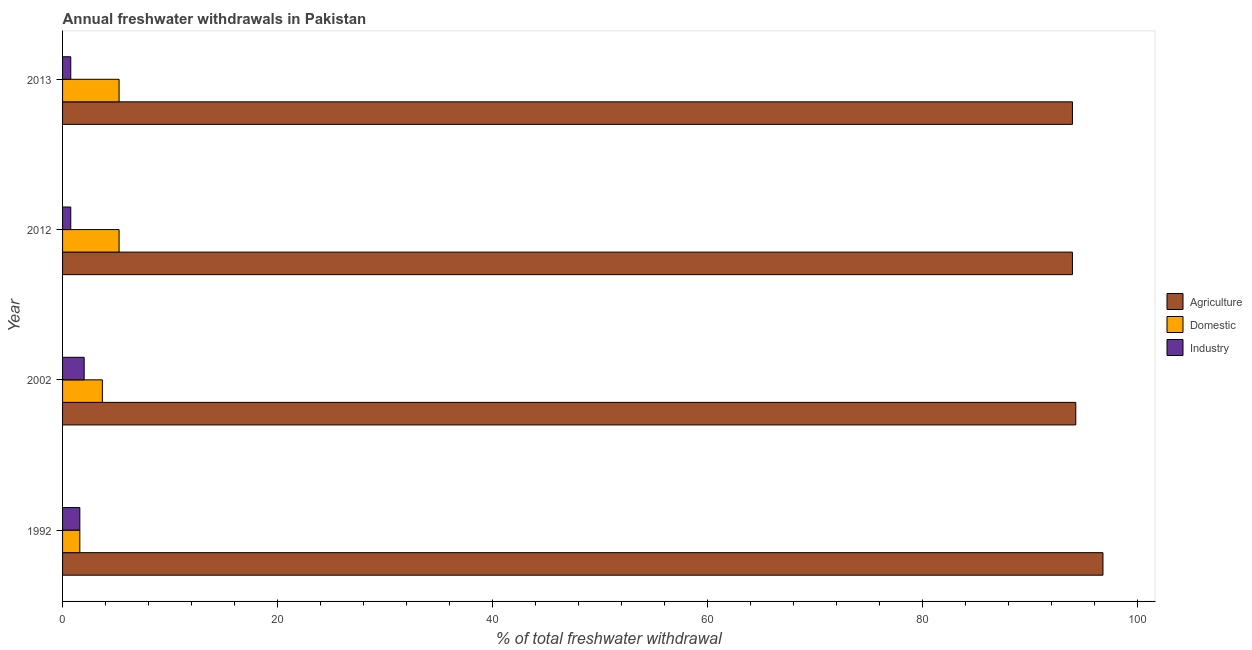How many different coloured bars are there?
Provide a short and direct response. 3. How many groups of bars are there?
Give a very brief answer. 4. Are the number of bars per tick equal to the number of legend labels?
Offer a very short reply. Yes. How many bars are there on the 1st tick from the top?
Your answer should be compact. 3. What is the label of the 3rd group of bars from the top?
Your response must be concise. 2002. In how many cases, is the number of bars for a given year not equal to the number of legend labels?
Your answer should be compact. 0. What is the percentage of freshwater withdrawal for industry in 2012?
Offer a very short reply. 0.76. Across all years, what is the maximum percentage of freshwater withdrawal for agriculture?
Offer a terse response. 96.79. Across all years, what is the minimum percentage of freshwater withdrawal for agriculture?
Offer a very short reply. 93.95. In which year was the percentage of freshwater withdrawal for domestic purposes minimum?
Keep it short and to the point. 1992. What is the total percentage of freshwater withdrawal for agriculture in the graph?
Your answer should be compact. 378.95. What is the difference between the percentage of freshwater withdrawal for industry in 2002 and that in 2012?
Ensure brevity in your answer.  1.25. What is the difference between the percentage of freshwater withdrawal for industry in 2012 and the percentage of freshwater withdrawal for agriculture in 2013?
Make the answer very short. -93.19. What is the average percentage of freshwater withdrawal for agriculture per year?
Provide a short and direct response. 94.74. In the year 2012, what is the difference between the percentage of freshwater withdrawal for agriculture and percentage of freshwater withdrawal for industry?
Your answer should be very brief. 93.19. In how many years, is the percentage of freshwater withdrawal for agriculture greater than 88 %?
Your response must be concise. 4. Is the percentage of freshwater withdrawal for domestic purposes in 1992 less than that in 2002?
Offer a terse response. Yes. Is the difference between the percentage of freshwater withdrawal for domestic purposes in 2002 and 2013 greater than the difference between the percentage of freshwater withdrawal for agriculture in 2002 and 2013?
Offer a very short reply. No. What is the difference between the highest and the lowest percentage of freshwater withdrawal for domestic purposes?
Provide a succinct answer. 3.65. In how many years, is the percentage of freshwater withdrawal for domestic purposes greater than the average percentage of freshwater withdrawal for domestic purposes taken over all years?
Your answer should be very brief. 2. Is the sum of the percentage of freshwater withdrawal for domestic purposes in 2002 and 2012 greater than the maximum percentage of freshwater withdrawal for industry across all years?
Your answer should be very brief. Yes. What does the 2nd bar from the top in 2002 represents?
Make the answer very short. Domestic. What does the 3rd bar from the bottom in 2012 represents?
Your answer should be very brief. Industry. How many bars are there?
Your answer should be compact. 12. How many years are there in the graph?
Give a very brief answer. 4. Are the values on the major ticks of X-axis written in scientific E-notation?
Keep it short and to the point. No. Does the graph contain any zero values?
Ensure brevity in your answer.  No. How many legend labels are there?
Give a very brief answer. 3. What is the title of the graph?
Offer a terse response. Annual freshwater withdrawals in Pakistan. What is the label or title of the X-axis?
Give a very brief answer. % of total freshwater withdrawal. What is the % of total freshwater withdrawal of Agriculture in 1992?
Provide a succinct answer. 96.79. What is the % of total freshwater withdrawal of Domestic in 1992?
Your answer should be very brief. 1.61. What is the % of total freshwater withdrawal of Industry in 1992?
Keep it short and to the point. 1.61. What is the % of total freshwater withdrawal in Agriculture in 2002?
Give a very brief answer. 94.26. What is the % of total freshwater withdrawal of Domestic in 2002?
Offer a very short reply. 3.7. What is the % of total freshwater withdrawal of Industry in 2002?
Provide a succinct answer. 2.01. What is the % of total freshwater withdrawal in Agriculture in 2012?
Your answer should be compact. 93.95. What is the % of total freshwater withdrawal in Domestic in 2012?
Provide a short and direct response. 5.26. What is the % of total freshwater withdrawal in Industry in 2012?
Make the answer very short. 0.76. What is the % of total freshwater withdrawal in Agriculture in 2013?
Provide a short and direct response. 93.95. What is the % of total freshwater withdrawal of Domestic in 2013?
Offer a terse response. 5.26. What is the % of total freshwater withdrawal of Industry in 2013?
Make the answer very short. 0.76. Across all years, what is the maximum % of total freshwater withdrawal of Agriculture?
Ensure brevity in your answer.  96.79. Across all years, what is the maximum % of total freshwater withdrawal in Domestic?
Offer a terse response. 5.26. Across all years, what is the maximum % of total freshwater withdrawal of Industry?
Your response must be concise. 2.01. Across all years, what is the minimum % of total freshwater withdrawal of Agriculture?
Your response must be concise. 93.95. Across all years, what is the minimum % of total freshwater withdrawal of Domestic?
Your answer should be compact. 1.61. Across all years, what is the minimum % of total freshwater withdrawal in Industry?
Offer a very short reply. 0.76. What is the total % of total freshwater withdrawal of Agriculture in the graph?
Offer a very short reply. 378.95. What is the total % of total freshwater withdrawal of Domestic in the graph?
Provide a succinct answer. 15.83. What is the total % of total freshwater withdrawal in Industry in the graph?
Offer a very short reply. 5.14. What is the difference between the % of total freshwater withdrawal of Agriculture in 1992 and that in 2002?
Make the answer very short. 2.53. What is the difference between the % of total freshwater withdrawal of Domestic in 1992 and that in 2002?
Your response must be concise. -2.1. What is the difference between the % of total freshwater withdrawal in Industry in 1992 and that in 2002?
Your response must be concise. -0.4. What is the difference between the % of total freshwater withdrawal of Agriculture in 1992 and that in 2012?
Your response must be concise. 2.84. What is the difference between the % of total freshwater withdrawal of Domestic in 1992 and that in 2012?
Offer a terse response. -3.65. What is the difference between the % of total freshwater withdrawal of Industry in 1992 and that in 2012?
Give a very brief answer. 0.84. What is the difference between the % of total freshwater withdrawal of Agriculture in 1992 and that in 2013?
Make the answer very short. 2.84. What is the difference between the % of total freshwater withdrawal of Domestic in 1992 and that in 2013?
Provide a short and direct response. -3.65. What is the difference between the % of total freshwater withdrawal of Industry in 1992 and that in 2013?
Provide a short and direct response. 0.84. What is the difference between the % of total freshwater withdrawal of Agriculture in 2002 and that in 2012?
Offer a terse response. 0.31. What is the difference between the % of total freshwater withdrawal in Domestic in 2002 and that in 2012?
Make the answer very short. -1.56. What is the difference between the % of total freshwater withdrawal in Industry in 2002 and that in 2012?
Provide a short and direct response. 1.25. What is the difference between the % of total freshwater withdrawal of Agriculture in 2002 and that in 2013?
Give a very brief answer. 0.31. What is the difference between the % of total freshwater withdrawal in Domestic in 2002 and that in 2013?
Provide a succinct answer. -1.56. What is the difference between the % of total freshwater withdrawal of Industry in 2002 and that in 2013?
Your response must be concise. 1.25. What is the difference between the % of total freshwater withdrawal in Industry in 2012 and that in 2013?
Provide a succinct answer. 0. What is the difference between the % of total freshwater withdrawal in Agriculture in 1992 and the % of total freshwater withdrawal in Domestic in 2002?
Offer a very short reply. 93.09. What is the difference between the % of total freshwater withdrawal of Agriculture in 1992 and the % of total freshwater withdrawal of Industry in 2002?
Ensure brevity in your answer.  94.78. What is the difference between the % of total freshwater withdrawal in Domestic in 1992 and the % of total freshwater withdrawal in Industry in 2002?
Provide a succinct answer. -0.4. What is the difference between the % of total freshwater withdrawal of Agriculture in 1992 and the % of total freshwater withdrawal of Domestic in 2012?
Your response must be concise. 91.53. What is the difference between the % of total freshwater withdrawal of Agriculture in 1992 and the % of total freshwater withdrawal of Industry in 2012?
Your response must be concise. 96.03. What is the difference between the % of total freshwater withdrawal in Domestic in 1992 and the % of total freshwater withdrawal in Industry in 2012?
Your response must be concise. 0.84. What is the difference between the % of total freshwater withdrawal of Agriculture in 1992 and the % of total freshwater withdrawal of Domestic in 2013?
Make the answer very short. 91.53. What is the difference between the % of total freshwater withdrawal of Agriculture in 1992 and the % of total freshwater withdrawal of Industry in 2013?
Offer a very short reply. 96.03. What is the difference between the % of total freshwater withdrawal of Domestic in 1992 and the % of total freshwater withdrawal of Industry in 2013?
Provide a short and direct response. 0.84. What is the difference between the % of total freshwater withdrawal of Agriculture in 2002 and the % of total freshwater withdrawal of Domestic in 2012?
Offer a terse response. 89. What is the difference between the % of total freshwater withdrawal of Agriculture in 2002 and the % of total freshwater withdrawal of Industry in 2012?
Your response must be concise. 93.5. What is the difference between the % of total freshwater withdrawal of Domestic in 2002 and the % of total freshwater withdrawal of Industry in 2012?
Keep it short and to the point. 2.94. What is the difference between the % of total freshwater withdrawal in Agriculture in 2002 and the % of total freshwater withdrawal in Domestic in 2013?
Offer a terse response. 89. What is the difference between the % of total freshwater withdrawal of Agriculture in 2002 and the % of total freshwater withdrawal of Industry in 2013?
Provide a succinct answer. 93.5. What is the difference between the % of total freshwater withdrawal in Domestic in 2002 and the % of total freshwater withdrawal in Industry in 2013?
Provide a succinct answer. 2.94. What is the difference between the % of total freshwater withdrawal of Agriculture in 2012 and the % of total freshwater withdrawal of Domestic in 2013?
Your answer should be very brief. 88.69. What is the difference between the % of total freshwater withdrawal of Agriculture in 2012 and the % of total freshwater withdrawal of Industry in 2013?
Provide a succinct answer. 93.19. What is the difference between the % of total freshwater withdrawal of Domestic in 2012 and the % of total freshwater withdrawal of Industry in 2013?
Keep it short and to the point. 4.5. What is the average % of total freshwater withdrawal of Agriculture per year?
Ensure brevity in your answer.  94.74. What is the average % of total freshwater withdrawal in Domestic per year?
Offer a very short reply. 3.96. In the year 1992, what is the difference between the % of total freshwater withdrawal of Agriculture and % of total freshwater withdrawal of Domestic?
Ensure brevity in your answer.  95.18. In the year 1992, what is the difference between the % of total freshwater withdrawal in Agriculture and % of total freshwater withdrawal in Industry?
Your response must be concise. 95.18. In the year 1992, what is the difference between the % of total freshwater withdrawal of Domestic and % of total freshwater withdrawal of Industry?
Your answer should be compact. 0. In the year 2002, what is the difference between the % of total freshwater withdrawal in Agriculture and % of total freshwater withdrawal in Domestic?
Keep it short and to the point. 90.56. In the year 2002, what is the difference between the % of total freshwater withdrawal in Agriculture and % of total freshwater withdrawal in Industry?
Make the answer very short. 92.25. In the year 2002, what is the difference between the % of total freshwater withdrawal in Domestic and % of total freshwater withdrawal in Industry?
Your response must be concise. 1.69. In the year 2012, what is the difference between the % of total freshwater withdrawal of Agriculture and % of total freshwater withdrawal of Domestic?
Offer a terse response. 88.69. In the year 2012, what is the difference between the % of total freshwater withdrawal in Agriculture and % of total freshwater withdrawal in Industry?
Your answer should be compact. 93.19. In the year 2012, what is the difference between the % of total freshwater withdrawal in Domestic and % of total freshwater withdrawal in Industry?
Provide a short and direct response. 4.5. In the year 2013, what is the difference between the % of total freshwater withdrawal of Agriculture and % of total freshwater withdrawal of Domestic?
Ensure brevity in your answer.  88.69. In the year 2013, what is the difference between the % of total freshwater withdrawal in Agriculture and % of total freshwater withdrawal in Industry?
Make the answer very short. 93.19. In the year 2013, what is the difference between the % of total freshwater withdrawal in Domestic and % of total freshwater withdrawal in Industry?
Your response must be concise. 4.5. What is the ratio of the % of total freshwater withdrawal of Agriculture in 1992 to that in 2002?
Offer a very short reply. 1.03. What is the ratio of the % of total freshwater withdrawal in Domestic in 1992 to that in 2002?
Offer a very short reply. 0.43. What is the ratio of the % of total freshwater withdrawal in Industry in 1992 to that in 2002?
Your response must be concise. 0.8. What is the ratio of the % of total freshwater withdrawal of Agriculture in 1992 to that in 2012?
Ensure brevity in your answer.  1.03. What is the ratio of the % of total freshwater withdrawal in Domestic in 1992 to that in 2012?
Make the answer very short. 0.31. What is the ratio of the % of total freshwater withdrawal of Industry in 1992 to that in 2012?
Ensure brevity in your answer.  2.11. What is the ratio of the % of total freshwater withdrawal in Agriculture in 1992 to that in 2013?
Offer a terse response. 1.03. What is the ratio of the % of total freshwater withdrawal of Domestic in 1992 to that in 2013?
Ensure brevity in your answer.  0.31. What is the ratio of the % of total freshwater withdrawal of Industry in 1992 to that in 2013?
Your answer should be compact. 2.11. What is the ratio of the % of total freshwater withdrawal of Agriculture in 2002 to that in 2012?
Your answer should be very brief. 1. What is the ratio of the % of total freshwater withdrawal of Domestic in 2002 to that in 2012?
Provide a succinct answer. 0.7. What is the ratio of the % of total freshwater withdrawal of Industry in 2002 to that in 2012?
Your answer should be very brief. 2.63. What is the ratio of the % of total freshwater withdrawal of Domestic in 2002 to that in 2013?
Offer a very short reply. 0.7. What is the ratio of the % of total freshwater withdrawal in Industry in 2002 to that in 2013?
Offer a very short reply. 2.63. What is the ratio of the % of total freshwater withdrawal of Domestic in 2012 to that in 2013?
Ensure brevity in your answer.  1. What is the difference between the highest and the second highest % of total freshwater withdrawal of Agriculture?
Your answer should be very brief. 2.53. What is the difference between the highest and the second highest % of total freshwater withdrawal of Domestic?
Keep it short and to the point. 0. What is the difference between the highest and the second highest % of total freshwater withdrawal in Industry?
Ensure brevity in your answer.  0.4. What is the difference between the highest and the lowest % of total freshwater withdrawal in Agriculture?
Offer a terse response. 2.84. What is the difference between the highest and the lowest % of total freshwater withdrawal in Domestic?
Give a very brief answer. 3.65. What is the difference between the highest and the lowest % of total freshwater withdrawal in Industry?
Your answer should be compact. 1.25. 